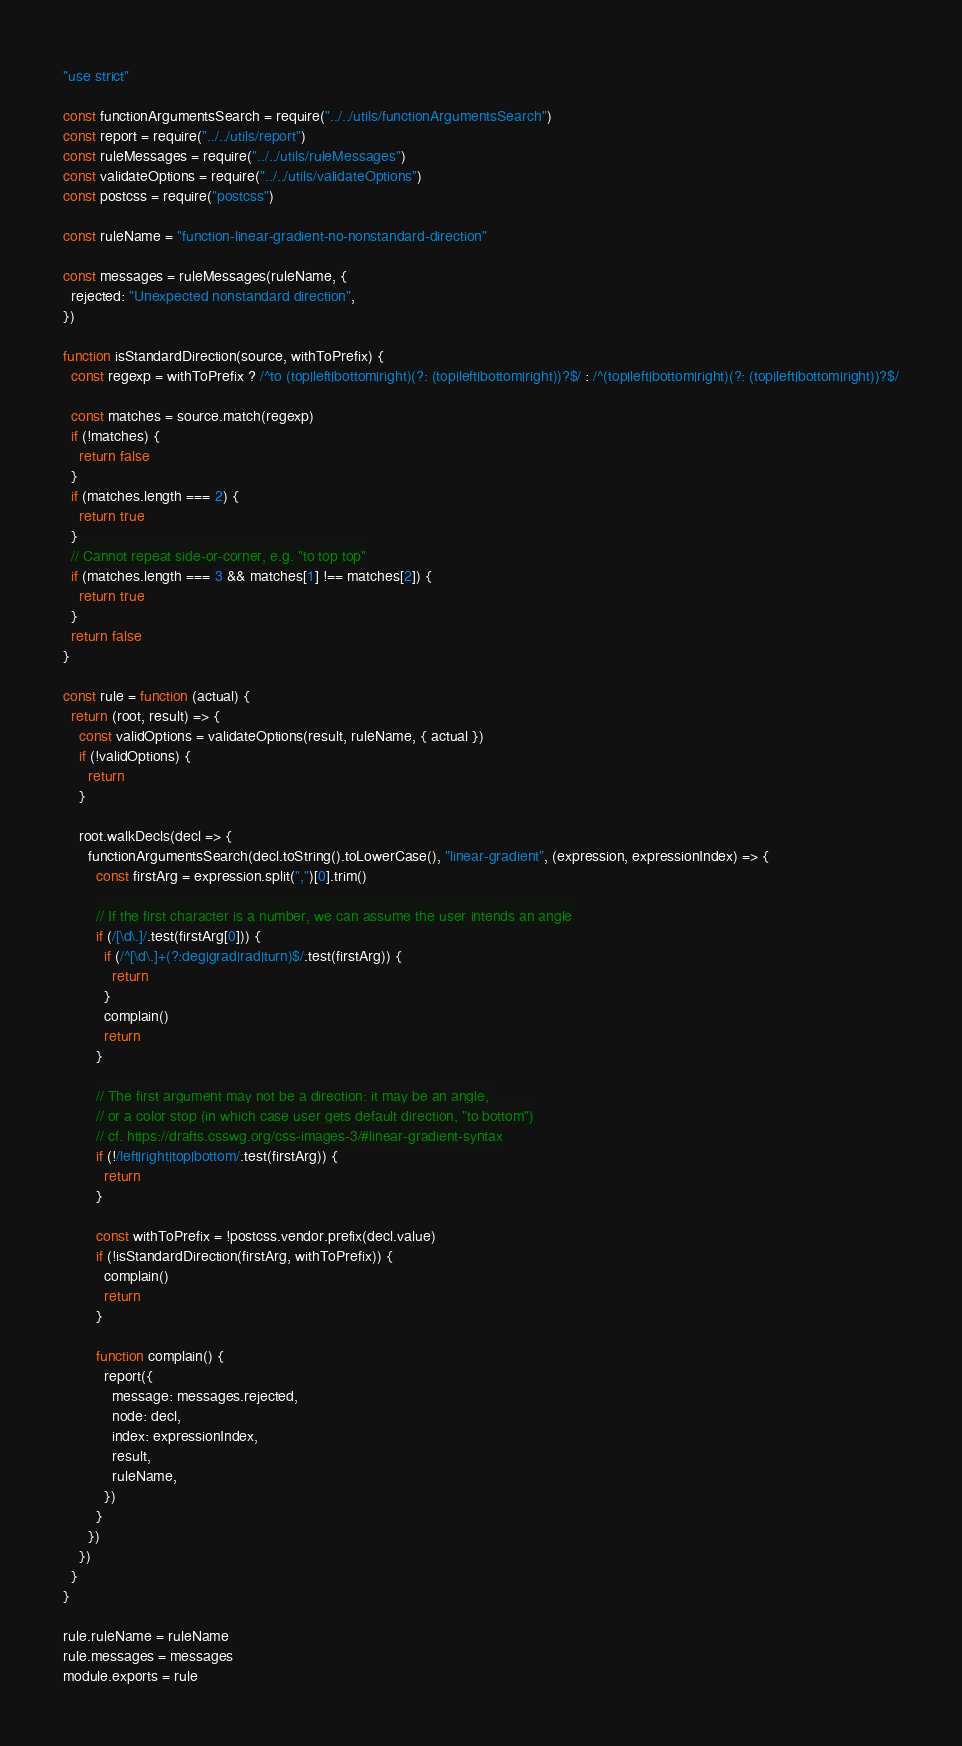Convert code to text. <code><loc_0><loc_0><loc_500><loc_500><_JavaScript_>"use strict"

const functionArgumentsSearch = require("../../utils/functionArgumentsSearch")
const report = require("../../utils/report")
const ruleMessages = require("../../utils/ruleMessages")
const validateOptions = require("../../utils/validateOptions")
const postcss = require("postcss")

const ruleName = "function-linear-gradient-no-nonstandard-direction"

const messages = ruleMessages(ruleName, {
  rejected: "Unexpected nonstandard direction",
})

function isStandardDirection(source, withToPrefix) {
  const regexp = withToPrefix ? /^to (top|left|bottom|right)(?: (top|left|bottom|right))?$/ : /^(top|left|bottom|right)(?: (top|left|bottom|right))?$/

  const matches = source.match(regexp)
  if (!matches) {
    return false
  }
  if (matches.length === 2) {
    return true
  }
  // Cannot repeat side-or-corner, e.g. "to top top"
  if (matches.length === 3 && matches[1] !== matches[2]) {
    return true
  }
  return false
}

const rule = function (actual) {
  return (root, result) => {
    const validOptions = validateOptions(result, ruleName, { actual })
    if (!validOptions) {
      return
    }

    root.walkDecls(decl => {
      functionArgumentsSearch(decl.toString().toLowerCase(), "linear-gradient", (expression, expressionIndex) => {
        const firstArg = expression.split(",")[0].trim()

        // If the first character is a number, we can assume the user intends an angle
        if (/[\d\.]/.test(firstArg[0])) {
          if (/^[\d\.]+(?:deg|grad|rad|turn)$/.test(firstArg)) {
            return
          }
          complain()
          return
        }

        // The first argument may not be a direction: it may be an angle,
        // or a color stop (in which case user gets default direction, "to bottom")
        // cf. https://drafts.csswg.org/css-images-3/#linear-gradient-syntax
        if (!/left|right|top|bottom/.test(firstArg)) {
          return
        }

        const withToPrefix = !postcss.vendor.prefix(decl.value)
        if (!isStandardDirection(firstArg, withToPrefix)) {
          complain()
          return
        }

        function complain() {
          report({
            message: messages.rejected,
            node: decl,
            index: expressionIndex,
            result,
            ruleName,
          })
        }
      })
    })
  }
}

rule.ruleName = ruleName
rule.messages = messages
module.exports = rule
</code> 